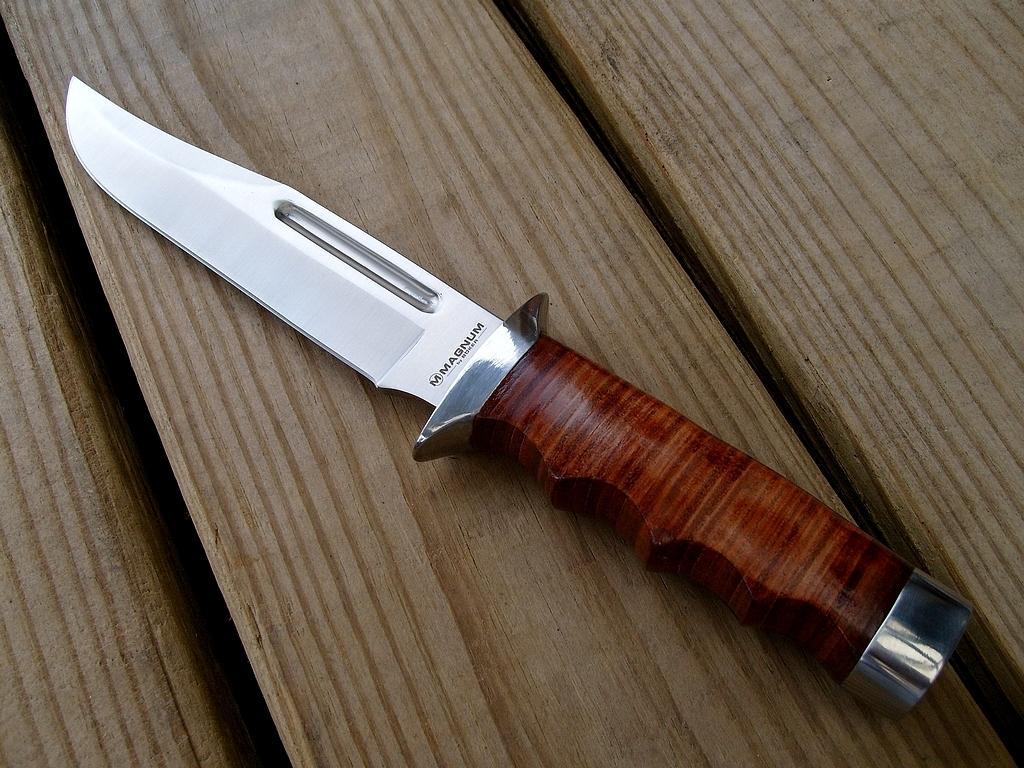In one or two sentences, can you explain what this image depicts? In the image there is a knife kept on the wooden table,the knife holder is made up of wood. 